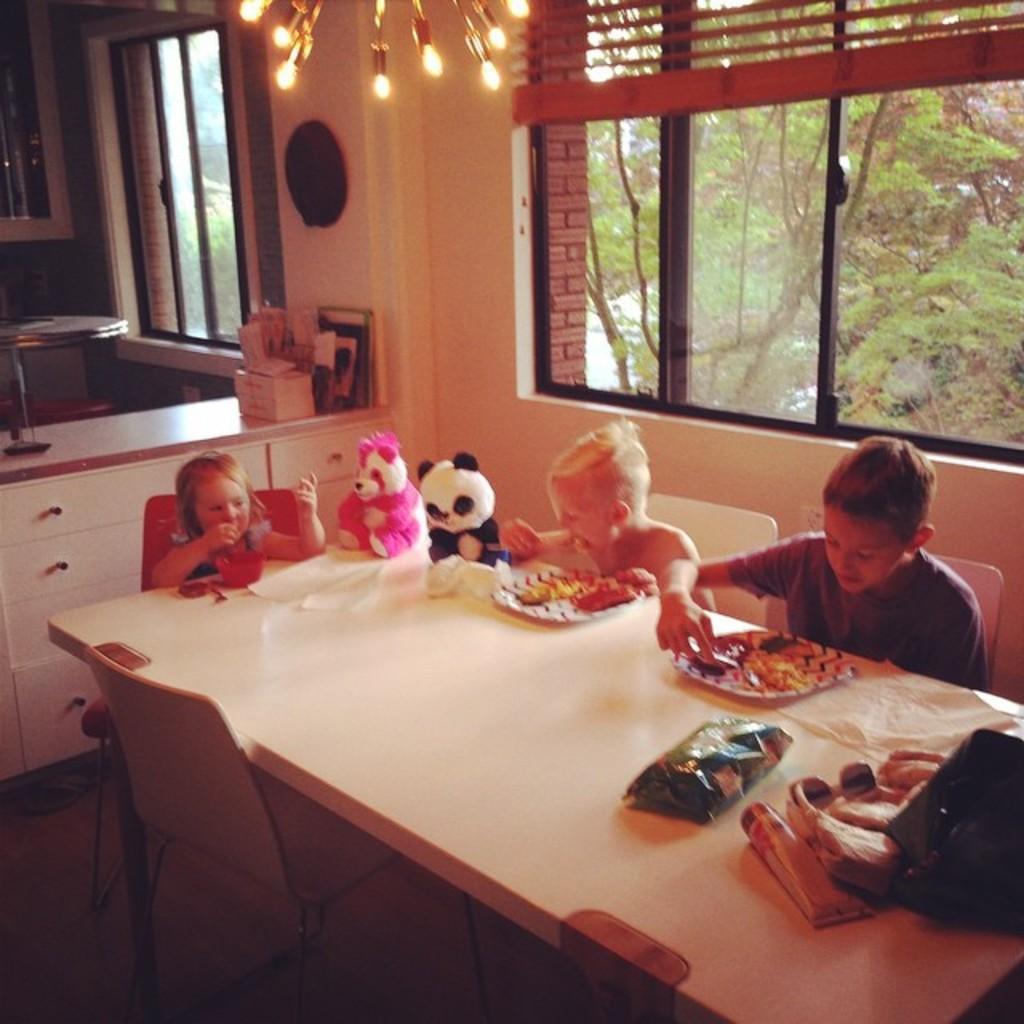How would you summarize this image in a sentence or two? In the image we can see three persons were sitting on the chair around the table. On table we can see some food items and in center we can see two teddy bears. And back we can see window,wall,mirror,trees and some more objects around them. 